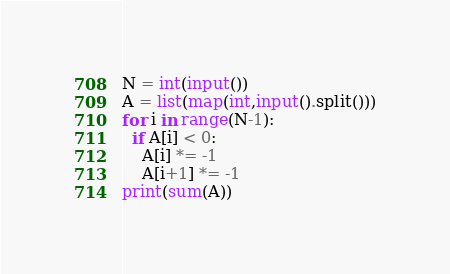<code> <loc_0><loc_0><loc_500><loc_500><_Python_>N = int(input())
A = list(map(int,input().split()))
for i in range(N-1):
  if A[i] < 0:
    A[i] *= -1
    A[i+1] *= -1
print(sum(A))</code> 